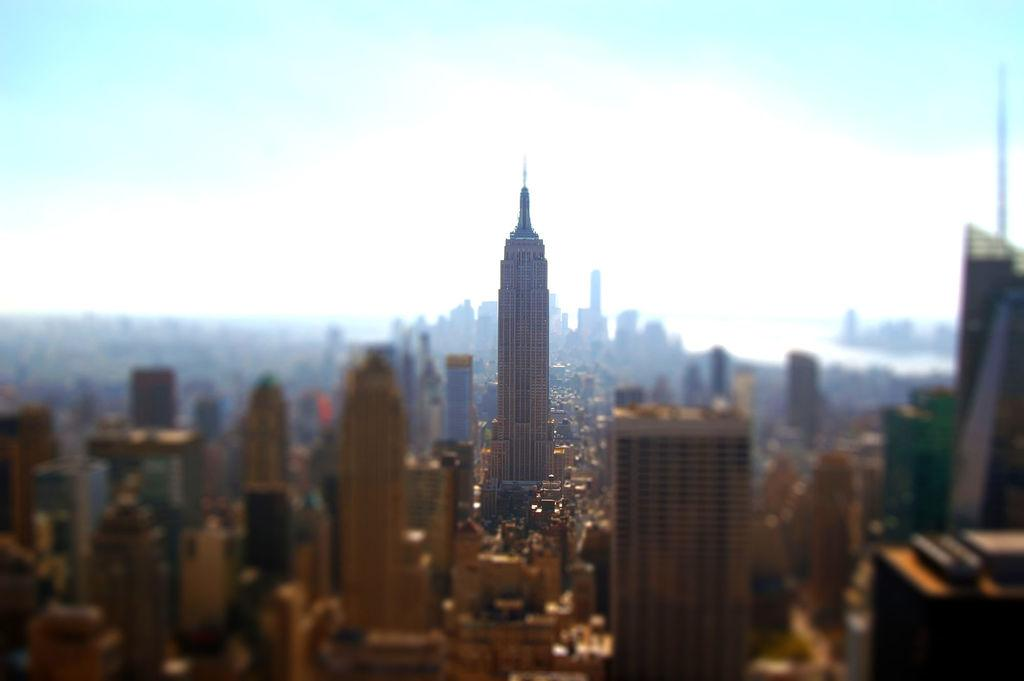What type of structures can be seen in the image? There are buildings in the image. What part of the natural environment is visible in the image? The sky is visible in the image. How would you describe the background of the image? The background of the image is blurred. What idea is being discussed in the image? There is no indication of a discussion or idea in the image; it primarily features buildings and the sky. 